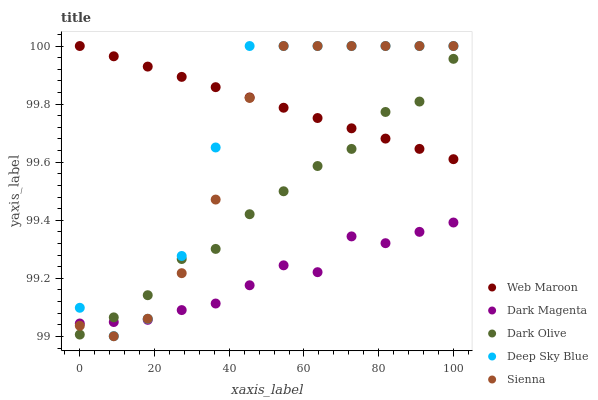Does Dark Magenta have the minimum area under the curve?
Answer yes or no. Yes. Does Web Maroon have the maximum area under the curve?
Answer yes or no. Yes. Does Dark Olive have the minimum area under the curve?
Answer yes or no. No. Does Dark Olive have the maximum area under the curve?
Answer yes or no. No. Is Web Maroon the smoothest?
Answer yes or no. Yes. Is Deep Sky Blue the roughest?
Answer yes or no. Yes. Is Dark Olive the smoothest?
Answer yes or no. No. Is Dark Olive the roughest?
Answer yes or no. No. Does Sienna have the lowest value?
Answer yes or no. Yes. Does Dark Olive have the lowest value?
Answer yes or no. No. Does Deep Sky Blue have the highest value?
Answer yes or no. Yes. Does Dark Olive have the highest value?
Answer yes or no. No. Is Dark Magenta less than Web Maroon?
Answer yes or no. Yes. Is Web Maroon greater than Dark Magenta?
Answer yes or no. Yes. Does Web Maroon intersect Sienna?
Answer yes or no. Yes. Is Web Maroon less than Sienna?
Answer yes or no. No. Is Web Maroon greater than Sienna?
Answer yes or no. No. Does Dark Magenta intersect Web Maroon?
Answer yes or no. No. 